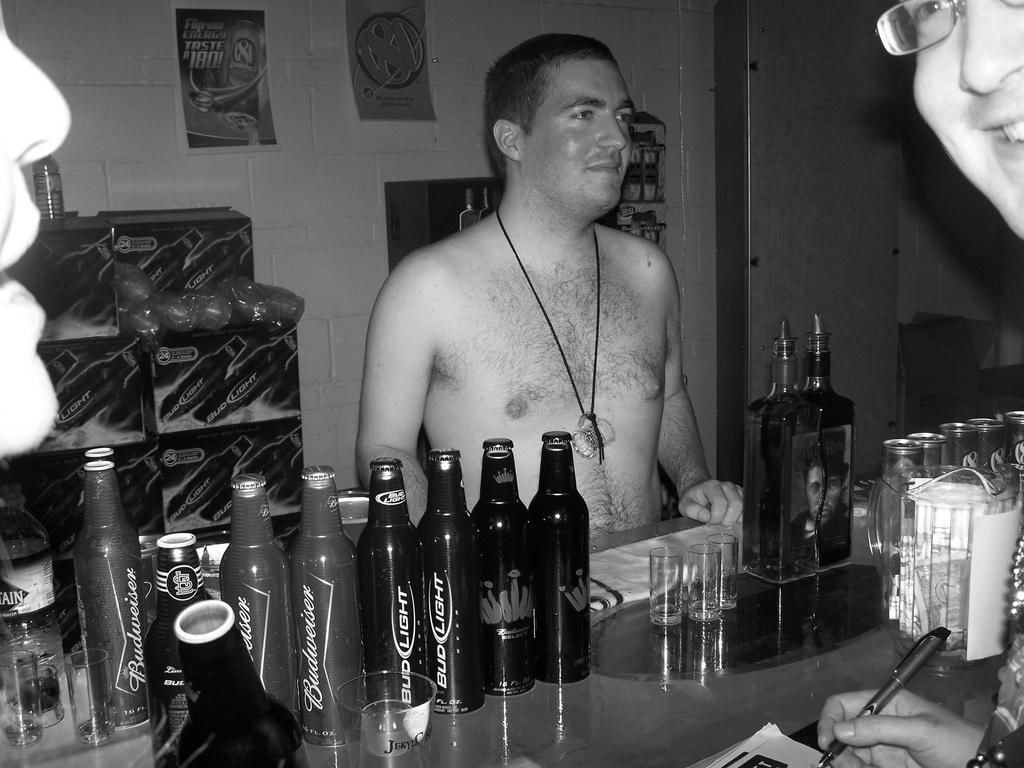What is there is a man standing in the image, what is he doing? There is a man standing in the image, and he is holding a pen and paper. What objects can be seen on the table in the image? There are bottles and peg glasses on the table in the image. Are there any decorations on the wall in the image? Yes, there are posters on the wall in the image. What type of skirt is the man wearing in the image? The man in the image is not wearing a skirt, as he is a man. 